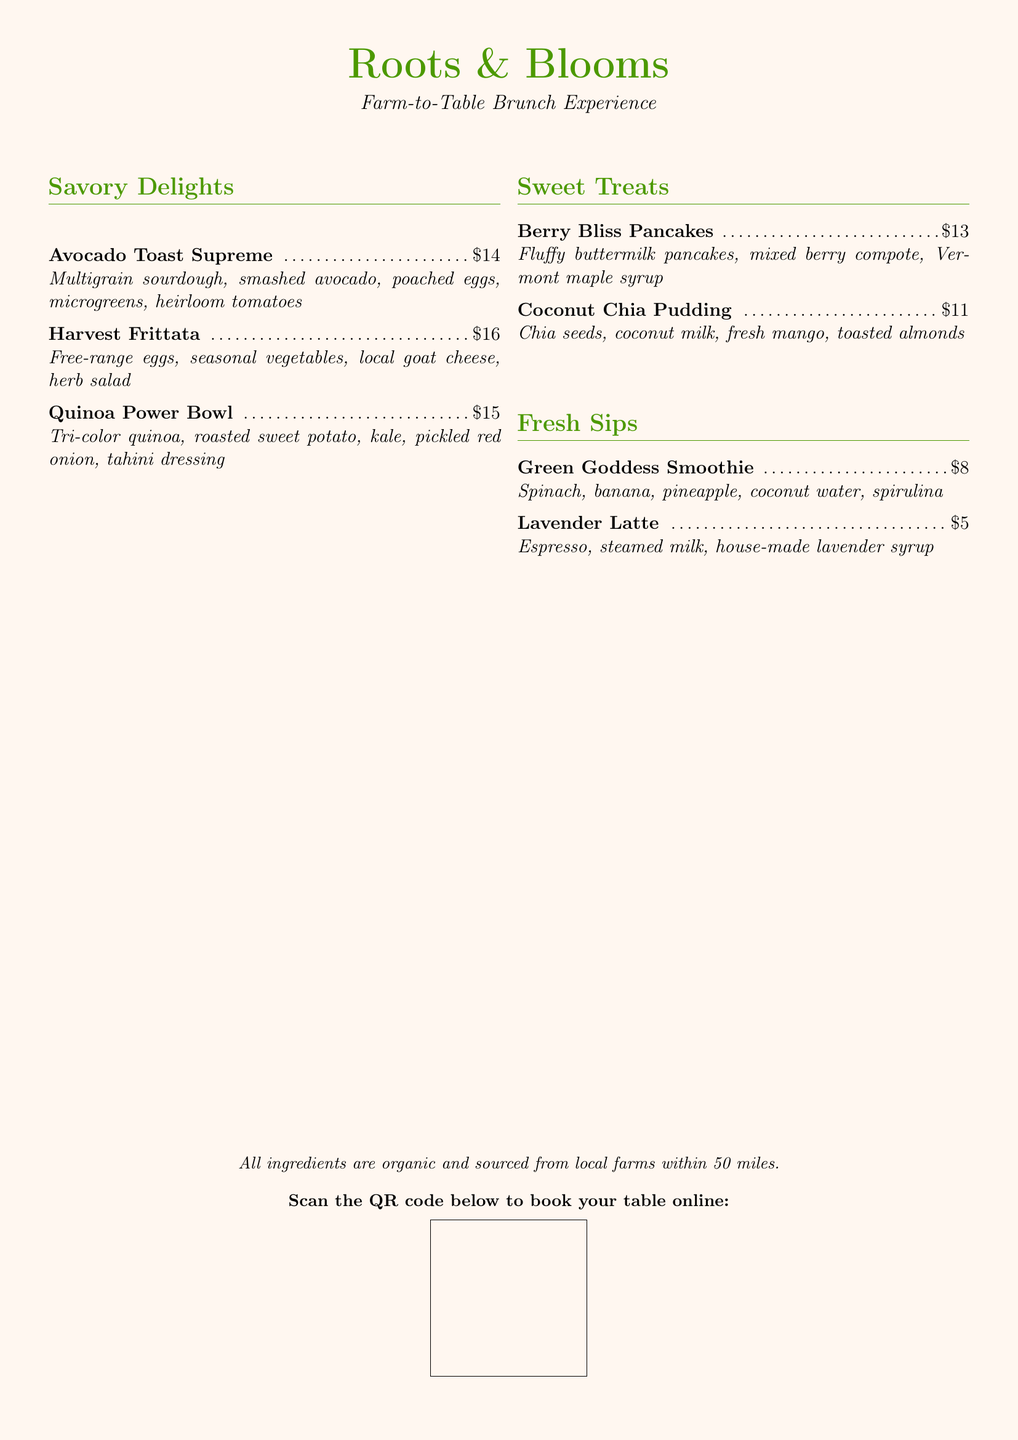What is the name of the brunch menu? The name of the brunch menu is presented at the top of the document.
Answer: Roots & Blooms How much does the Avocado Toast Supreme cost? The cost of the Avocado Toast Supreme is listed next to the item.
Answer: $14 What type of eggs are used in the Harvest Frittata? The type of eggs is mentioned in the description of the Harvest Frittata.
Answer: Free-range What is the main ingredient in the Coconut Chia Pudding? The main ingredient is specified in the name of the item.
Answer: Chia seeds How many types of pancakes are available? This can be determined by counting the listed items in the Sweet Treats section.
Answer: One What are the ingredients in the Green Goddess Smoothie? The ingredients are listed in the description of the Green Goddess Smoothie.
Answer: Spinach, banana, pineapple, coconut water, spirulina What type of syrup is used in the Lavender Latte? The type of syrup is described in the ingredients for the Lavender Latte.
Answer: House-made lavender syrup How far are the ingredients sourced from? The distance is stated in the last section of the document.
Answer: 50 miles What does the QR code allow customers to do? The function of the QR code is explained in the text below it.
Answer: Book your table online 